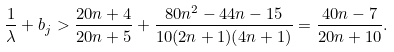<formula> <loc_0><loc_0><loc_500><loc_500>\frac { 1 } { \lambda } + b _ { j } > \frac { 2 0 n + 4 } { 2 0 n + 5 } + \frac { 8 0 n ^ { 2 } - 4 4 n - 1 5 } { 1 0 ( 2 n + 1 ) ( 4 n + 1 ) } = \frac { 4 0 n - 7 } { 2 0 n + 1 0 } .</formula> 